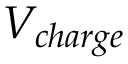Convert formula to latex. <formula><loc_0><loc_0><loc_500><loc_500>V _ { c h \arg e }</formula> 